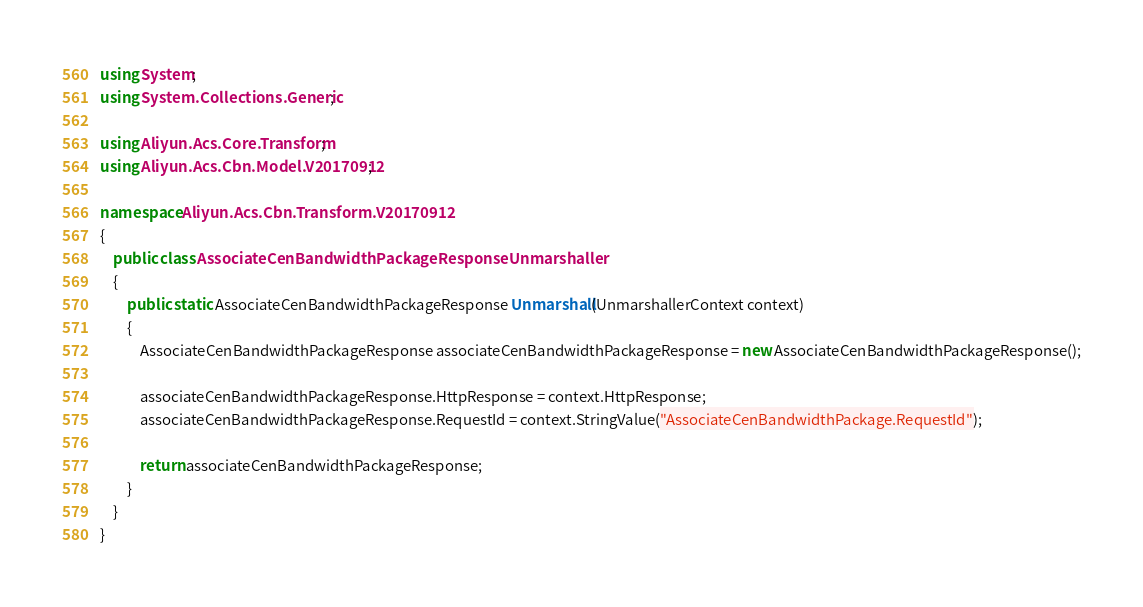Convert code to text. <code><loc_0><loc_0><loc_500><loc_500><_C#_>using System;
using System.Collections.Generic;

using Aliyun.Acs.Core.Transform;
using Aliyun.Acs.Cbn.Model.V20170912;

namespace Aliyun.Acs.Cbn.Transform.V20170912
{
    public class AssociateCenBandwidthPackageResponseUnmarshaller
    {
        public static AssociateCenBandwidthPackageResponse Unmarshall(UnmarshallerContext context)
        {
			AssociateCenBandwidthPackageResponse associateCenBandwidthPackageResponse = new AssociateCenBandwidthPackageResponse();

			associateCenBandwidthPackageResponse.HttpResponse = context.HttpResponse;
			associateCenBandwidthPackageResponse.RequestId = context.StringValue("AssociateCenBandwidthPackage.RequestId");
        
			return associateCenBandwidthPackageResponse;
        }
    }
}
</code> 